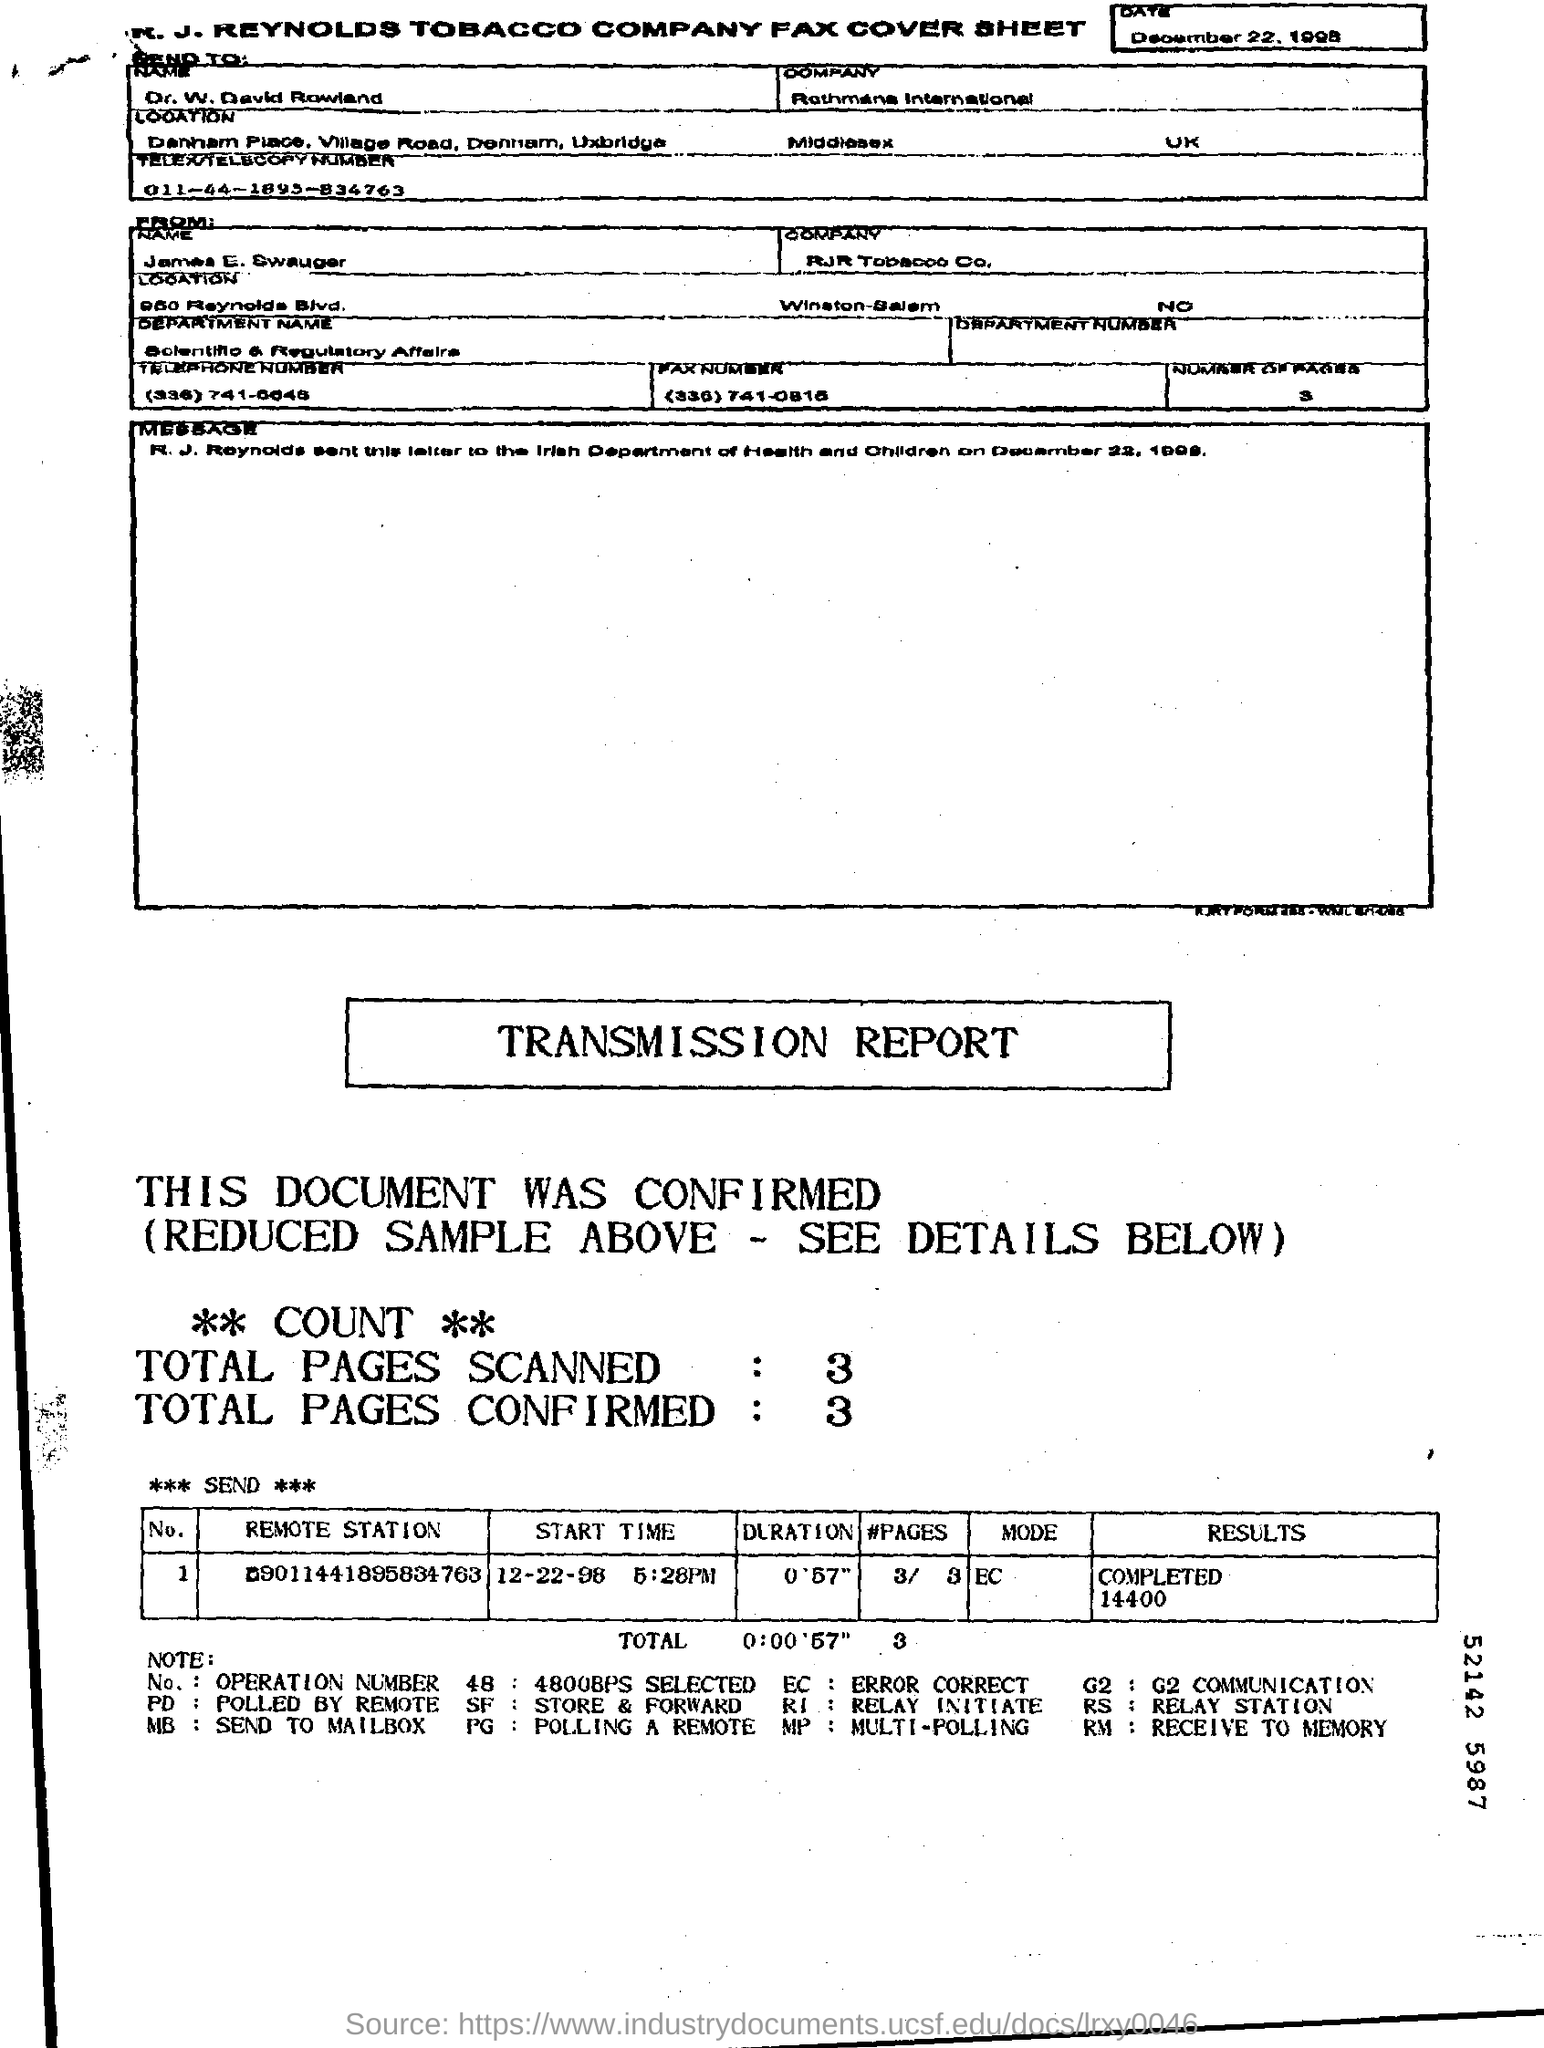Identify some key points in this picture. The fax is addressed to Dr. W. David Rowland. 